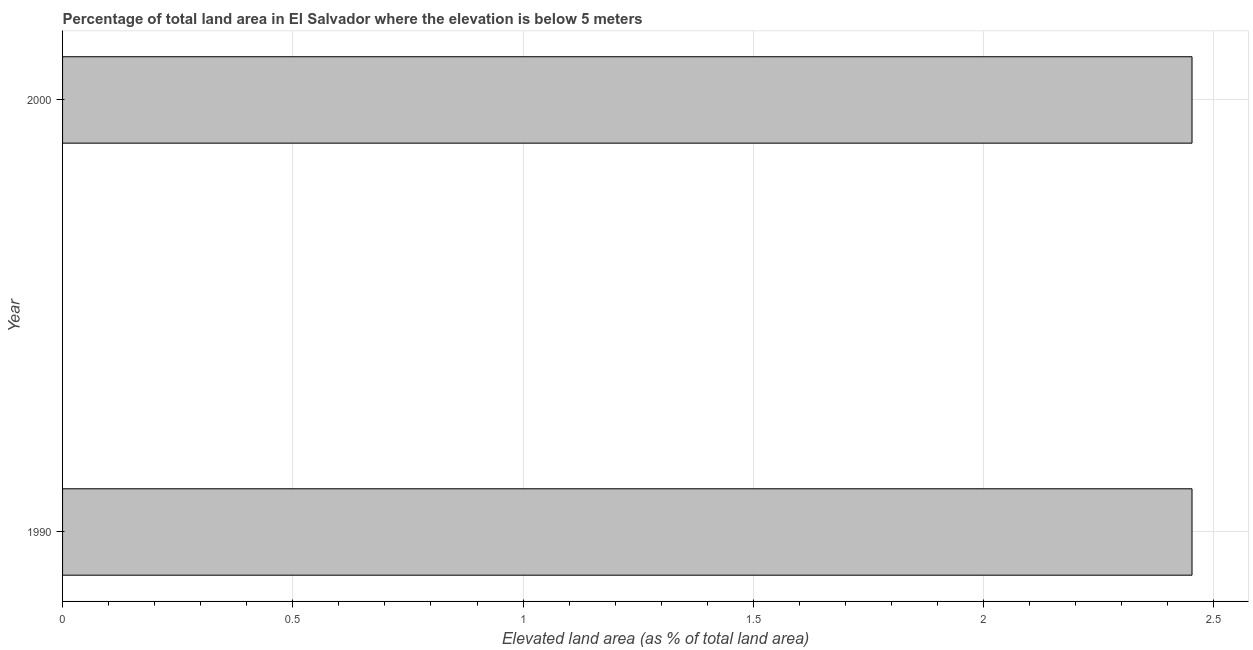Does the graph contain any zero values?
Your answer should be compact. No. Does the graph contain grids?
Your answer should be very brief. Yes. What is the title of the graph?
Provide a succinct answer. Percentage of total land area in El Salvador where the elevation is below 5 meters. What is the label or title of the X-axis?
Keep it short and to the point. Elevated land area (as % of total land area). What is the total elevated land area in 2000?
Provide a short and direct response. 2.45. Across all years, what is the maximum total elevated land area?
Your answer should be compact. 2.45. Across all years, what is the minimum total elevated land area?
Provide a short and direct response. 2.45. In which year was the total elevated land area maximum?
Provide a short and direct response. 1990. In which year was the total elevated land area minimum?
Provide a succinct answer. 1990. What is the sum of the total elevated land area?
Your response must be concise. 4.91. What is the average total elevated land area per year?
Provide a succinct answer. 2.45. What is the median total elevated land area?
Your response must be concise. 2.45. In how many years, is the total elevated land area greater than 1.5 %?
Your response must be concise. 2. Is the total elevated land area in 1990 less than that in 2000?
Ensure brevity in your answer.  No. In how many years, is the total elevated land area greater than the average total elevated land area taken over all years?
Ensure brevity in your answer.  0. Are all the bars in the graph horizontal?
Provide a succinct answer. Yes. How many years are there in the graph?
Offer a very short reply. 2. What is the difference between two consecutive major ticks on the X-axis?
Make the answer very short. 0.5. Are the values on the major ticks of X-axis written in scientific E-notation?
Ensure brevity in your answer.  No. What is the Elevated land area (as % of total land area) in 1990?
Provide a succinct answer. 2.45. What is the Elevated land area (as % of total land area) of 2000?
Provide a short and direct response. 2.45. What is the difference between the Elevated land area (as % of total land area) in 1990 and 2000?
Provide a succinct answer. 0. What is the ratio of the Elevated land area (as % of total land area) in 1990 to that in 2000?
Keep it short and to the point. 1. 